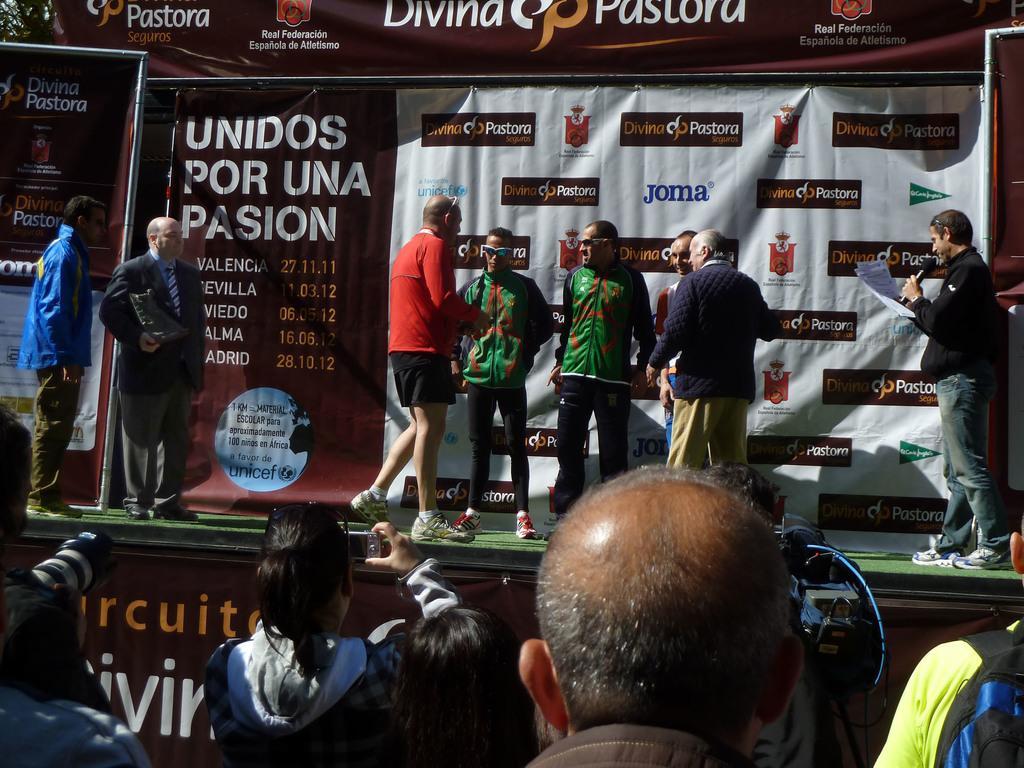Please provide a concise description of this image. In this picture there are group of people standing on the stage. On the right side of the image there are is a person standing and holding the microphone and paper. In the middle of the image there are group of people standing. On the left side of the image there is a person with grey suit is standing and holding the object. At the back there are hoardings. In the top left there is a tree. In the foreground there are group of people standing and few are holding the camera. 